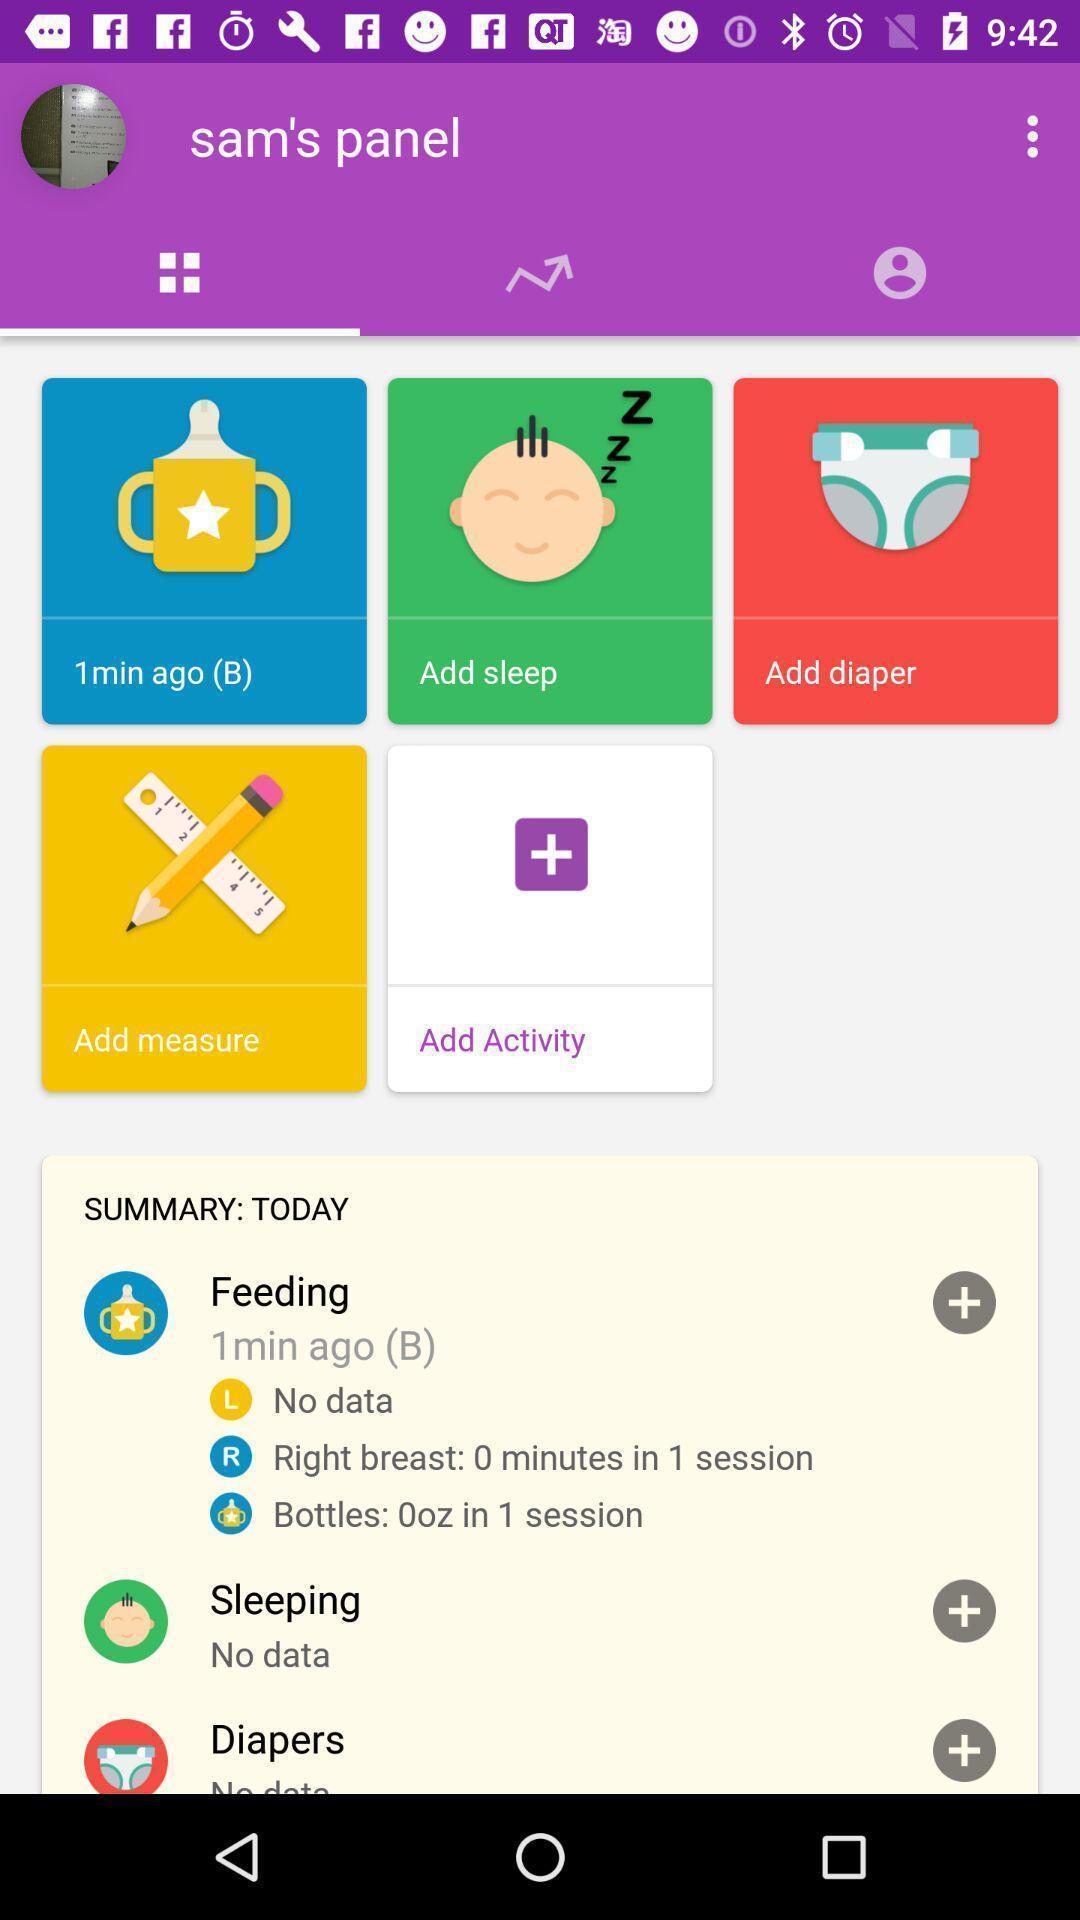What is the overall content of this screenshot? Profile page featuring several options. 